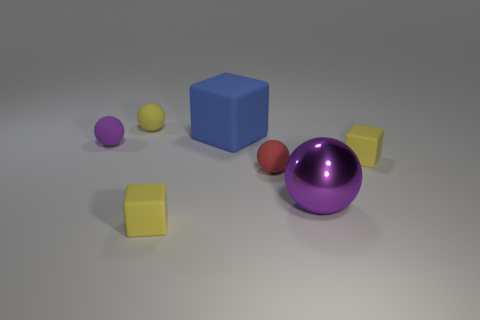Add 3 big red metal objects. How many objects exist? 10 Subtract all blue spheres. Subtract all green blocks. How many spheres are left? 4 Subtract all blocks. How many objects are left? 4 Add 2 small matte spheres. How many small matte spheres are left? 5 Add 1 tiny yellow rubber balls. How many tiny yellow rubber balls exist? 2 Subtract 0 brown blocks. How many objects are left? 7 Subtract all big rubber cubes. Subtract all tiny red cylinders. How many objects are left? 6 